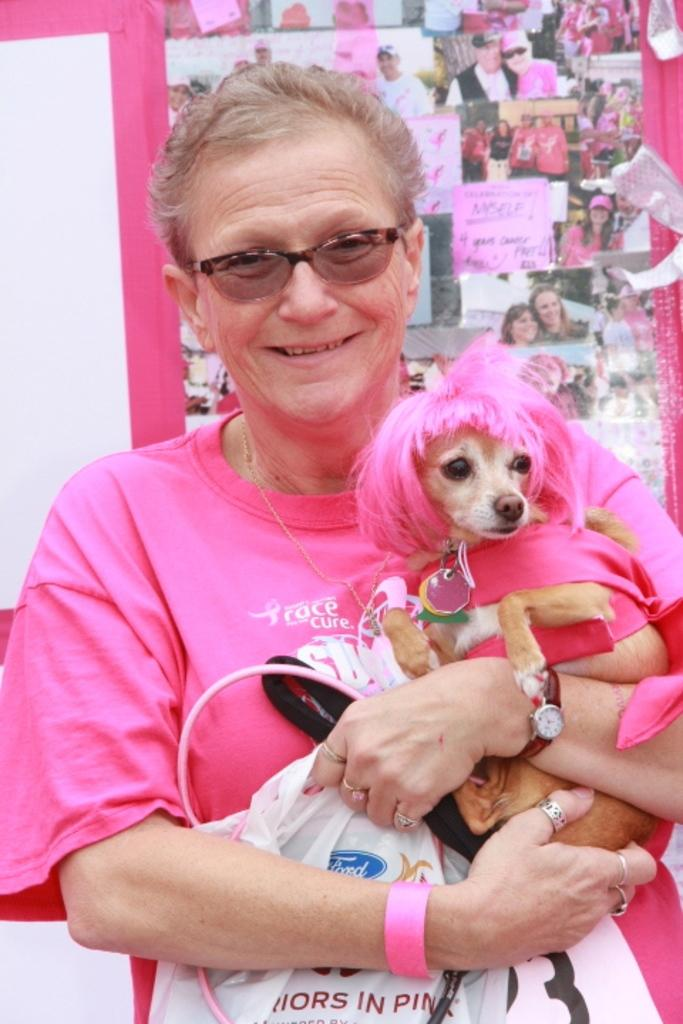What is the man in the image doing? The man is standing in the image and holding a puppy in his hand. What can be seen in the background of the image? There are photos and letters in the background of the image. What type of bone is the puppy chewing on in the image? There is no bone present in the image; the man is holding the puppy in his hand. How does the puppy help the man gain knowledge in the image? The image does not depict the puppy helping the man gain knowledge, as the focus is on the man holding the puppy. 